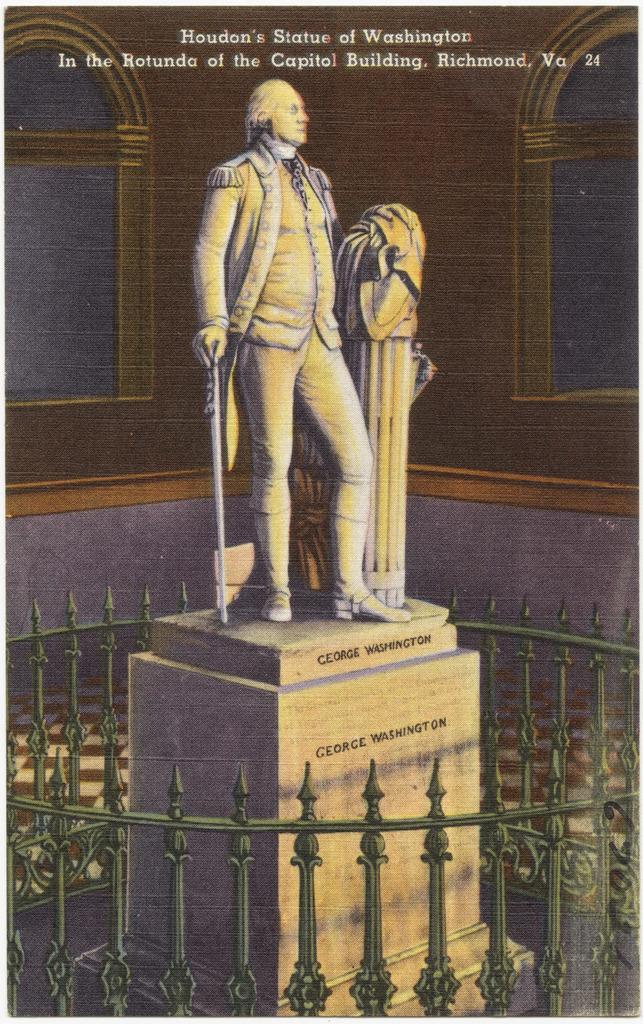Describe this image in one or two sentences. In this image we can see the statue of a person. A person is holding an object. There is a fence in the image. There is some text at the top of the image. 